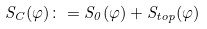<formula> <loc_0><loc_0><loc_500><loc_500>S _ { C } ( \varphi ) \colon = S _ { 0 } ( \varphi ) + S _ { t o p } ( \varphi )</formula> 